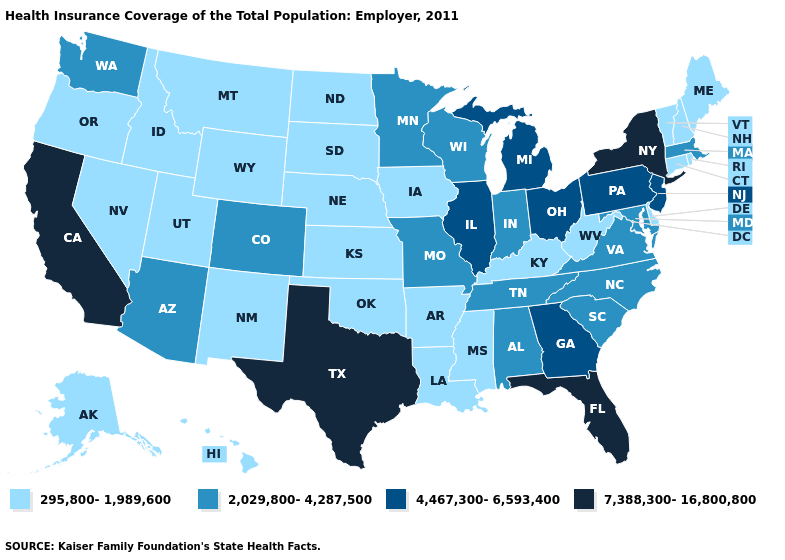What is the highest value in states that border Indiana?
Answer briefly. 4,467,300-6,593,400. What is the highest value in the USA?
Answer briefly. 7,388,300-16,800,800. Among the states that border Kansas , which have the lowest value?
Quick response, please. Nebraska, Oklahoma. What is the lowest value in states that border Ohio?
Give a very brief answer. 295,800-1,989,600. Name the states that have a value in the range 7,388,300-16,800,800?
Keep it brief. California, Florida, New York, Texas. Name the states that have a value in the range 7,388,300-16,800,800?
Be succinct. California, Florida, New York, Texas. What is the value of Oregon?
Give a very brief answer. 295,800-1,989,600. Which states have the highest value in the USA?
Answer briefly. California, Florida, New York, Texas. Does the map have missing data?
Concise answer only. No. Which states have the lowest value in the USA?
Keep it brief. Alaska, Arkansas, Connecticut, Delaware, Hawaii, Idaho, Iowa, Kansas, Kentucky, Louisiana, Maine, Mississippi, Montana, Nebraska, Nevada, New Hampshire, New Mexico, North Dakota, Oklahoma, Oregon, Rhode Island, South Dakota, Utah, Vermont, West Virginia, Wyoming. Among the states that border Idaho , which have the highest value?
Write a very short answer. Washington. Which states have the lowest value in the USA?
Write a very short answer. Alaska, Arkansas, Connecticut, Delaware, Hawaii, Idaho, Iowa, Kansas, Kentucky, Louisiana, Maine, Mississippi, Montana, Nebraska, Nevada, New Hampshire, New Mexico, North Dakota, Oklahoma, Oregon, Rhode Island, South Dakota, Utah, Vermont, West Virginia, Wyoming. What is the value of Arizona?
Keep it brief. 2,029,800-4,287,500. Does Kansas have a higher value than Michigan?
Give a very brief answer. No. 